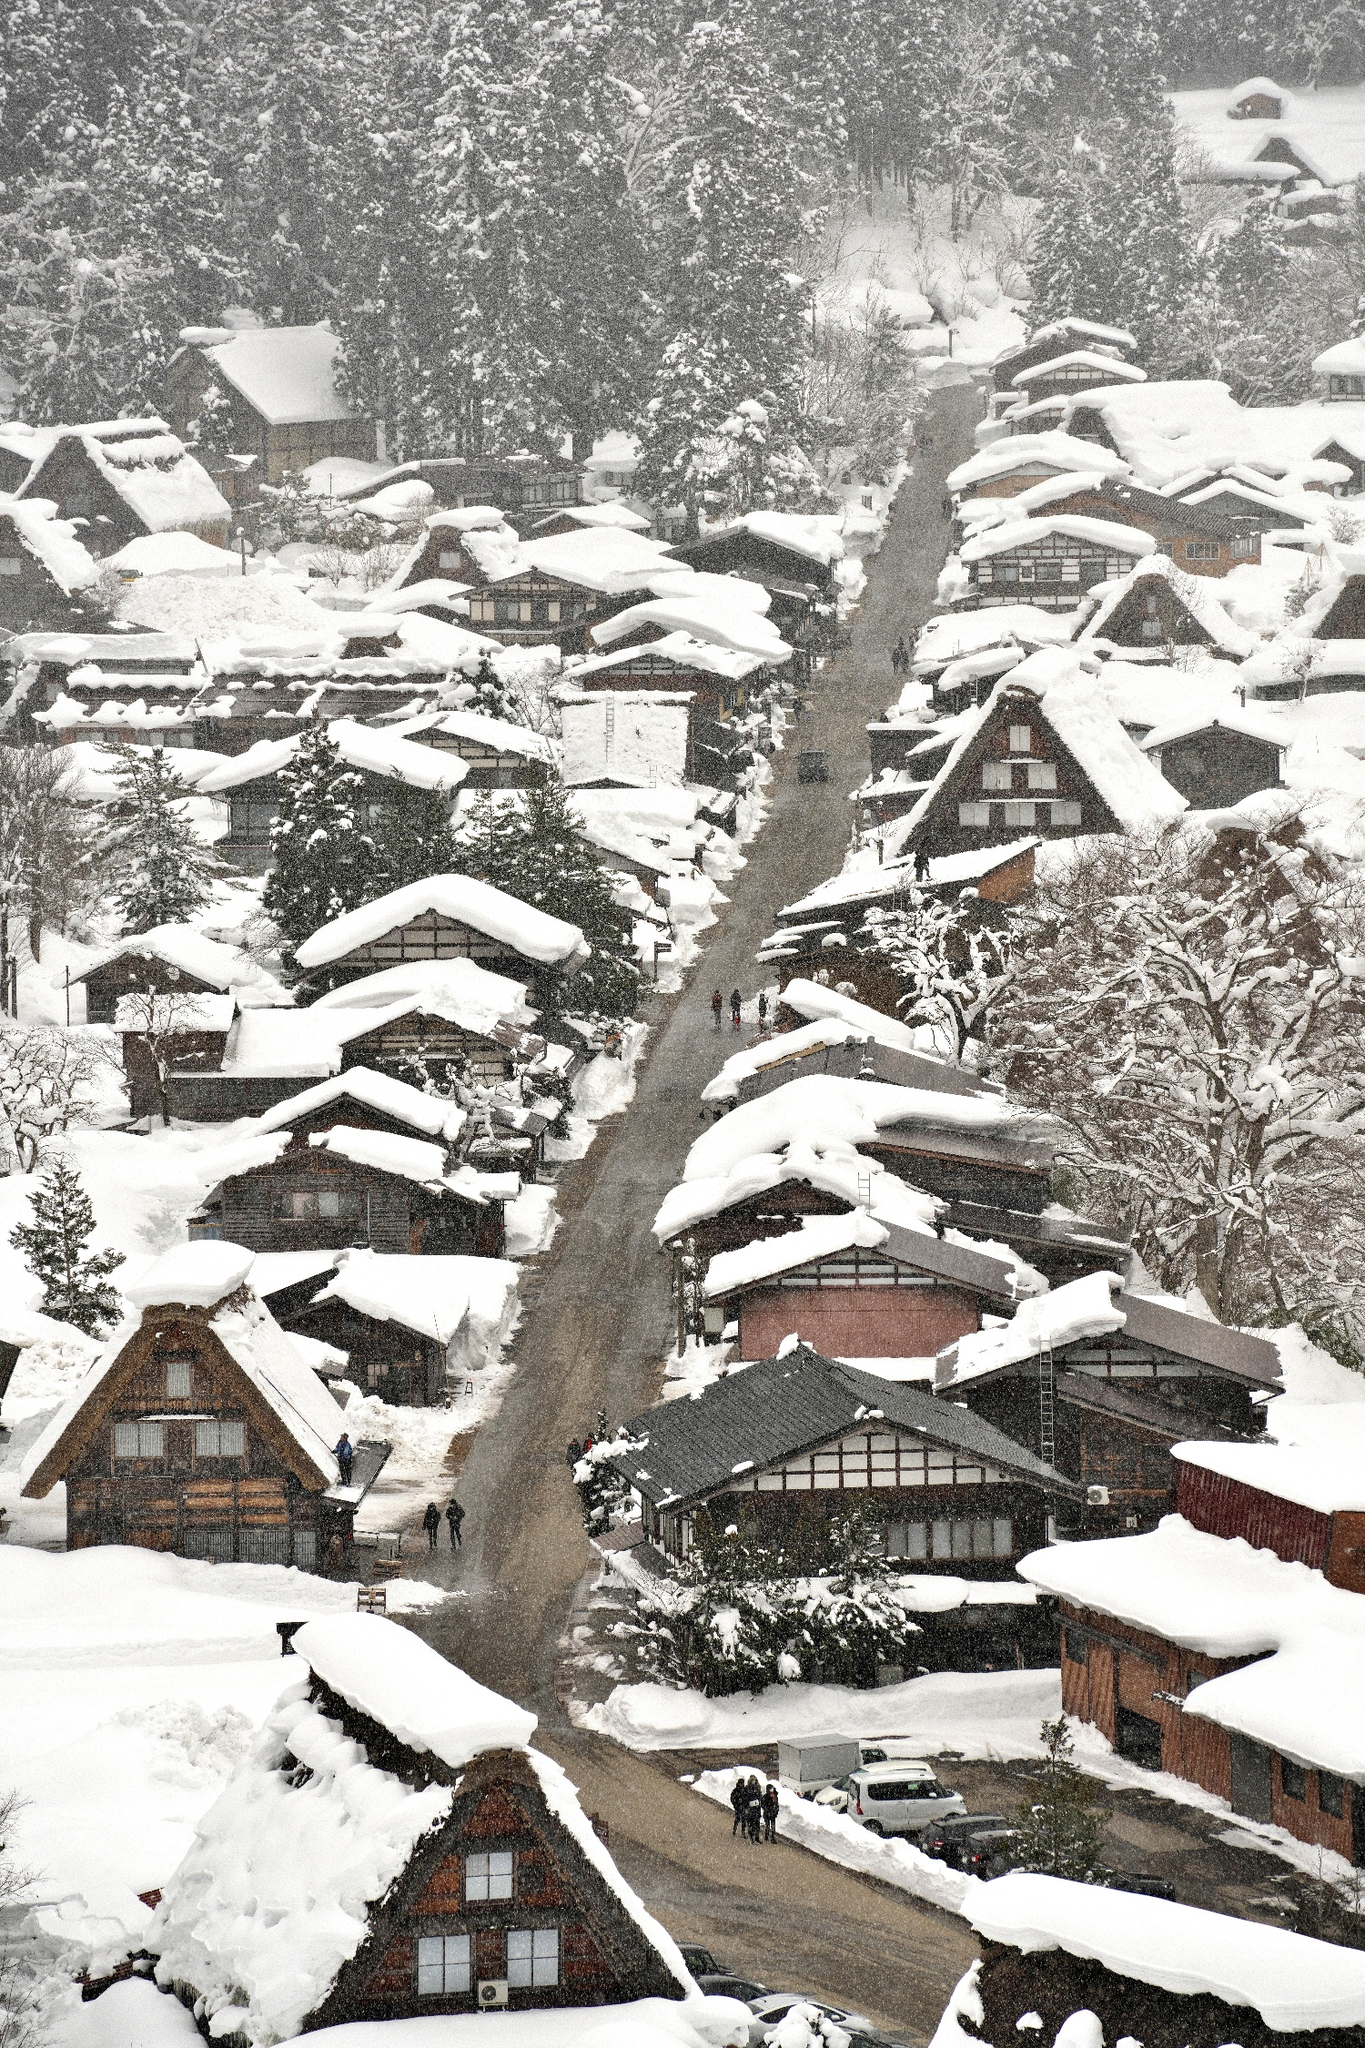What is this photo about? This breathtaking photo showcases Shirakawa-go, a historic village in Japan renowned for its gassho-zukuri farmhouses. These farmhouses are depicted with steep thatched roofs designed to withstand the heavy snowfall visible in the image. Located in a remote valley, this view captures the village during winter, blanketed in snow which emphasizes the tranquil, almost timeless character of this World Heritage Site. The overcast sky casts a soft, diffuse light, enhancing the serene and isolated feel of the landscape. This scene captures both the cultural significance and the stunning natural beauty of Shirakawa-go in winter. 